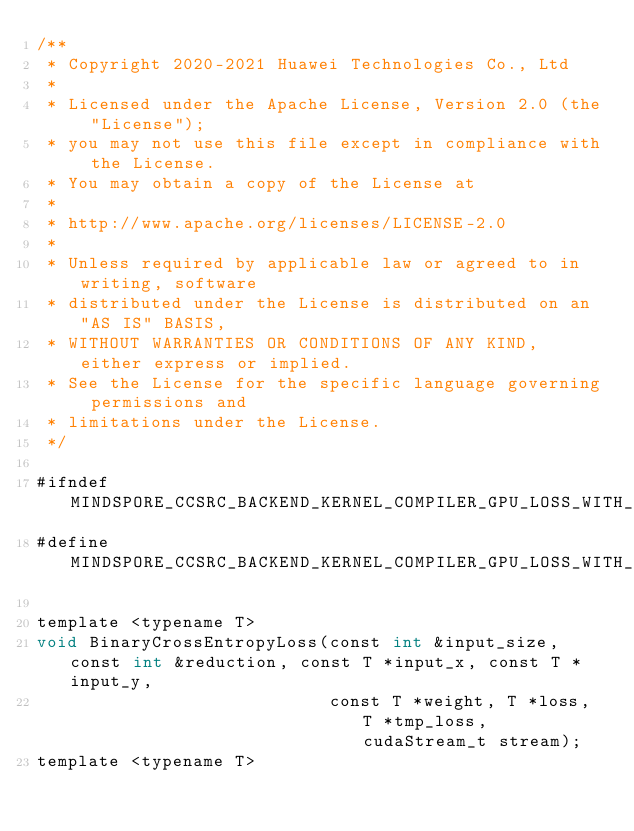<code> <loc_0><loc_0><loc_500><loc_500><_Cuda_>/**
 * Copyright 2020-2021 Huawei Technologies Co., Ltd
 *
 * Licensed under the Apache License, Version 2.0 (the "License");
 * you may not use this file except in compliance with the License.
 * You may obtain a copy of the License at
 *
 * http://www.apache.org/licenses/LICENSE-2.0
 *
 * Unless required by applicable law or agreed to in writing, software
 * distributed under the License is distributed on an "AS IS" BASIS,
 * WITHOUT WARRANTIES OR CONDITIONS OF ANY KIND, either express or implied.
 * See the License for the specific language governing permissions and
 * limitations under the License.
 */

#ifndef MINDSPORE_CCSRC_BACKEND_KERNEL_COMPILER_GPU_LOSS_WITH_REDUCTION_IMPL_CUH
#define MINDSPORE_CCSRC_BACKEND_KERNEL_COMPILER_GPU_LOSS_WITH_REDUCTION_IMPL_CUH

template <typename T>
void BinaryCrossEntropyLoss(const int &input_size, const int &reduction, const T *input_x, const T *input_y,
                            const T *weight, T *loss, T *tmp_loss, cudaStream_t stream);
template <typename T></code> 